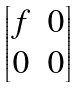<formula> <loc_0><loc_0><loc_500><loc_500>\begin{bmatrix} f & 0 \\ 0 & 0 \end{bmatrix}</formula> 